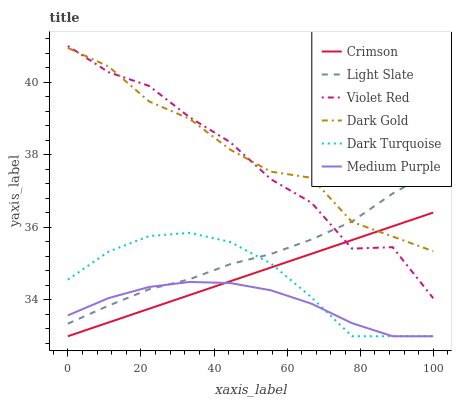Does Medium Purple have the minimum area under the curve?
Answer yes or no. Yes. Does Dark Gold have the maximum area under the curve?
Answer yes or no. Yes. Does Light Slate have the minimum area under the curve?
Answer yes or no. No. Does Light Slate have the maximum area under the curve?
Answer yes or no. No. Is Crimson the smoothest?
Answer yes or no. Yes. Is Violet Red the roughest?
Answer yes or no. Yes. Is Dark Gold the smoothest?
Answer yes or no. No. Is Dark Gold the roughest?
Answer yes or no. No. Does Dark Turquoise have the lowest value?
Answer yes or no. Yes. Does Light Slate have the lowest value?
Answer yes or no. No. Does Violet Red have the highest value?
Answer yes or no. Yes. Does Dark Gold have the highest value?
Answer yes or no. No. Is Dark Turquoise less than Dark Gold?
Answer yes or no. Yes. Is Light Slate greater than Crimson?
Answer yes or no. Yes. Does Crimson intersect Dark Gold?
Answer yes or no. Yes. Is Crimson less than Dark Gold?
Answer yes or no. No. Is Crimson greater than Dark Gold?
Answer yes or no. No. Does Dark Turquoise intersect Dark Gold?
Answer yes or no. No. 